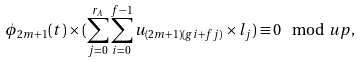Convert formula to latex. <formula><loc_0><loc_0><loc_500><loc_500>\phi _ { 2 m + 1 } ( t ) \times ( \sum _ { j = 0 } ^ { r _ { A } } \sum _ { i = 0 } ^ { f - 1 } u _ { ( 2 m + 1 ) ( g i + f j ) } \times l _ { j } ) \equiv 0 \mod u p ,</formula> 